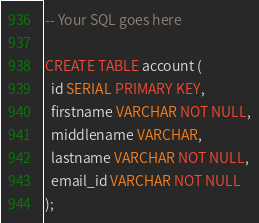Convert code to text. <code><loc_0><loc_0><loc_500><loc_500><_SQL_>-- Your SQL goes here

CREATE TABLE account (
  id SERIAL PRIMARY KEY,
  firstname VARCHAR NOT NULL,
  middlename VARCHAR,
  lastname VARCHAR NOT NULL,
  email_id VARCHAR NOT NULL
);
</code> 